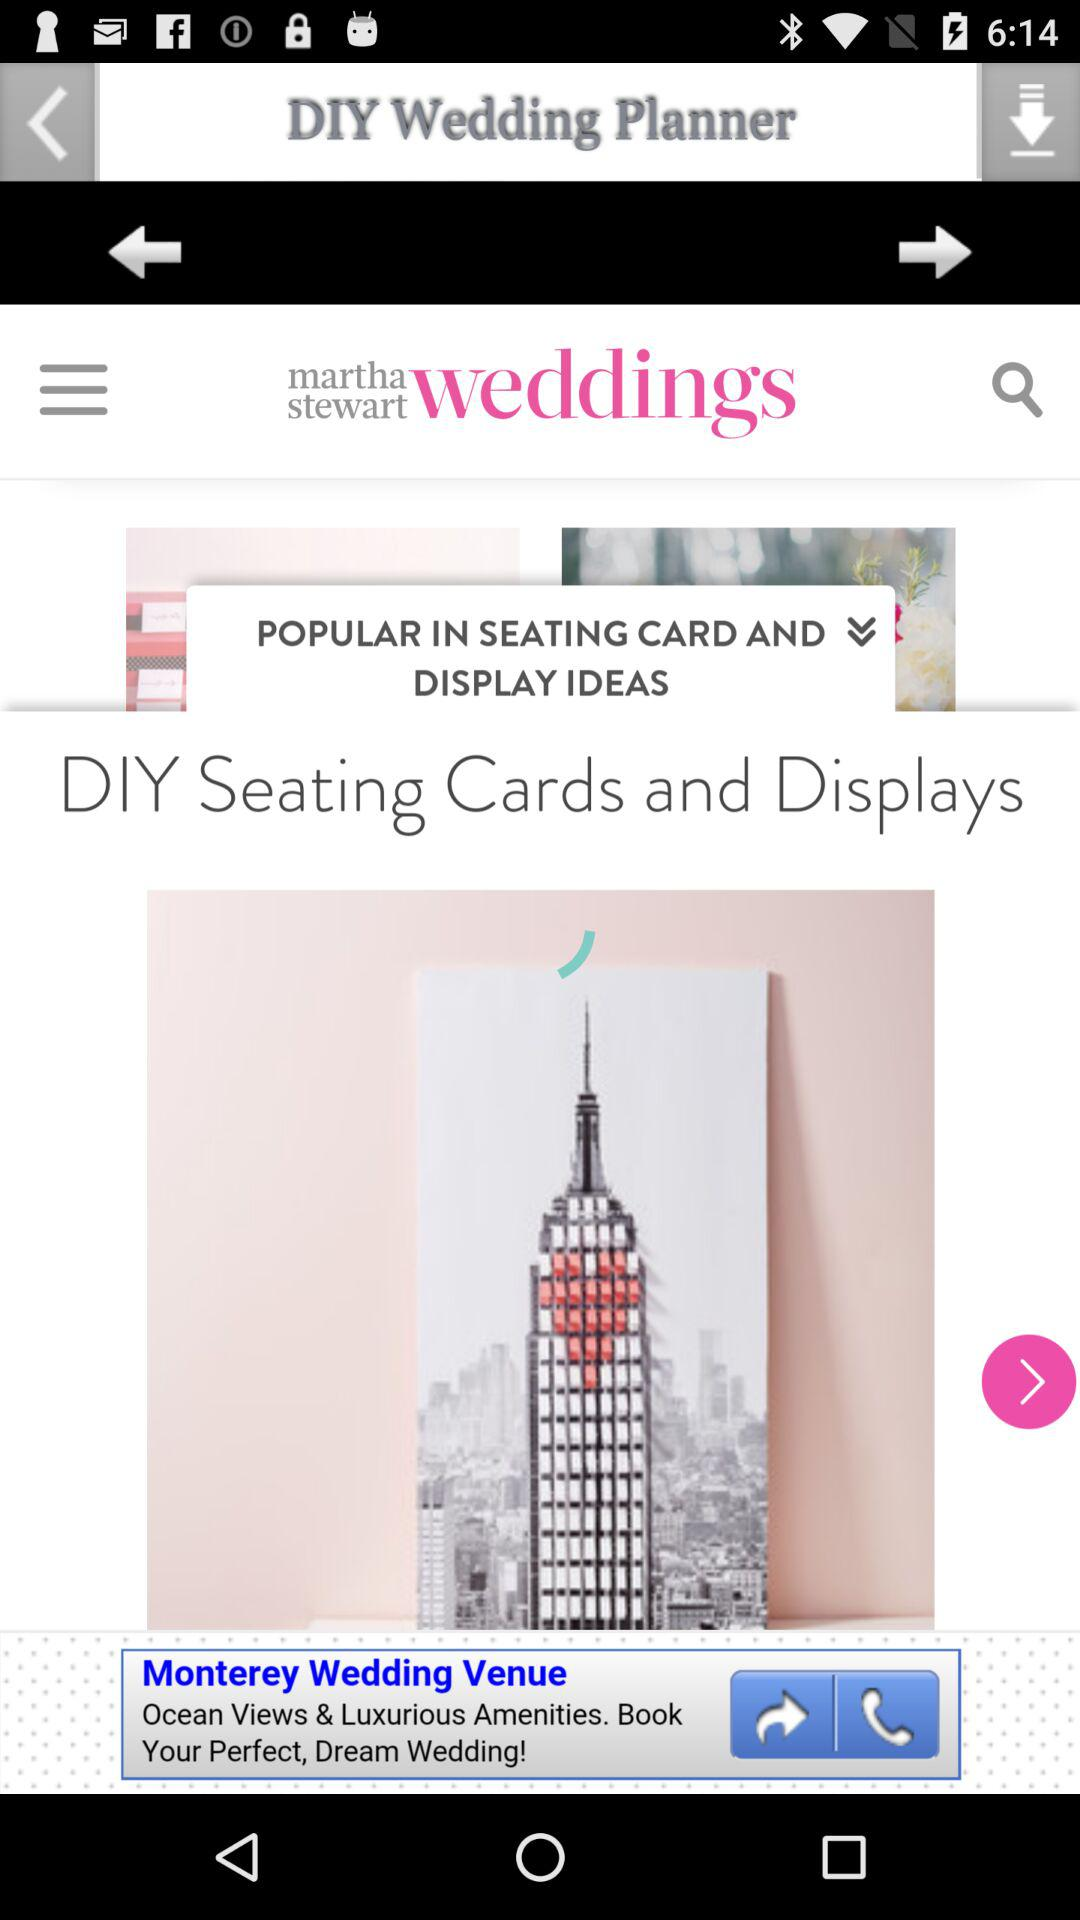What is the application name? The application name is "DIY Wedding Planner". 